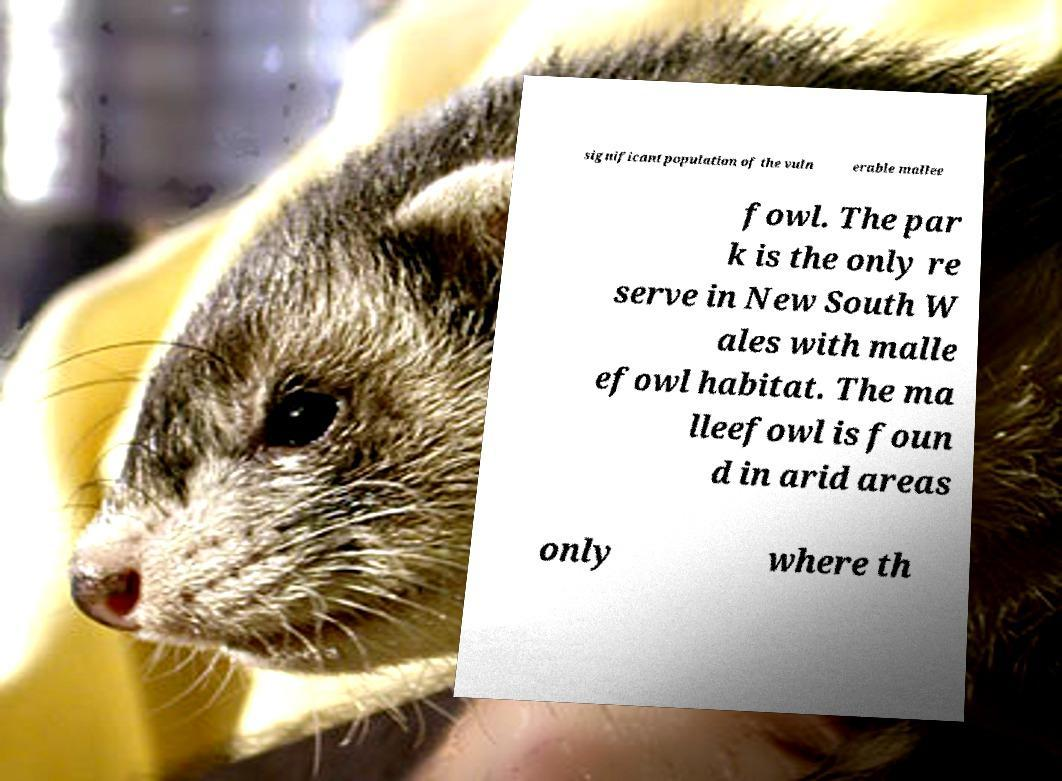For documentation purposes, I need the text within this image transcribed. Could you provide that? significant population of the vuln erable mallee fowl. The par k is the only re serve in New South W ales with malle efowl habitat. The ma lleefowl is foun d in arid areas only where th 